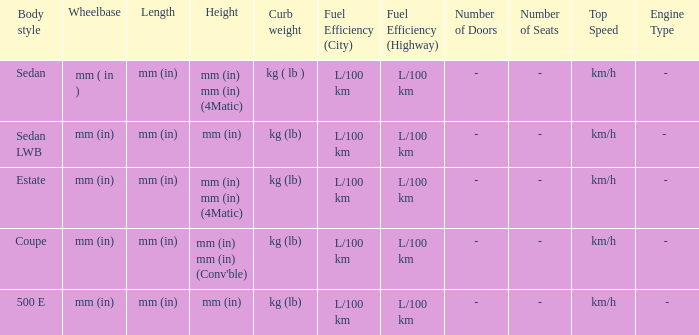What are the lengths of the models that are mm (in) tall? Mm (in), mm (in). 